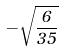<formula> <loc_0><loc_0><loc_500><loc_500>- \sqrt { \frac { 6 } { 3 5 } }</formula> 